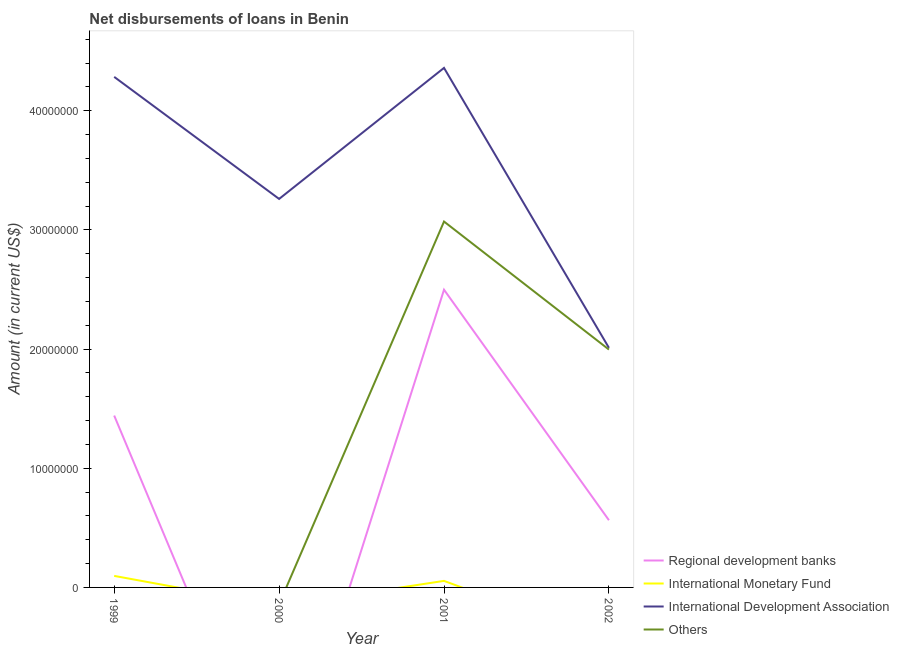How many different coloured lines are there?
Provide a succinct answer. 4. Is the number of lines equal to the number of legend labels?
Give a very brief answer. No. What is the amount of loan disimbursed by regional development banks in 2001?
Provide a succinct answer. 2.50e+07. Across all years, what is the maximum amount of loan disimbursed by other organisations?
Give a very brief answer. 3.07e+07. In which year was the amount of loan disimbursed by international development association maximum?
Give a very brief answer. 2001. What is the total amount of loan disimbursed by regional development banks in the graph?
Your answer should be very brief. 4.50e+07. What is the difference between the amount of loan disimbursed by international development association in 2001 and that in 2002?
Ensure brevity in your answer.  2.35e+07. What is the difference between the amount of loan disimbursed by international development association in 2001 and the amount of loan disimbursed by other organisations in 1999?
Offer a very short reply. 4.36e+07. What is the average amount of loan disimbursed by regional development banks per year?
Offer a terse response. 1.13e+07. In the year 2002, what is the difference between the amount of loan disimbursed by international development association and amount of loan disimbursed by regional development banks?
Give a very brief answer. 1.45e+07. What is the ratio of the amount of loan disimbursed by regional development banks in 1999 to that in 2001?
Provide a short and direct response. 0.58. What is the difference between the highest and the second highest amount of loan disimbursed by international development association?
Make the answer very short. 7.53e+05. What is the difference between the highest and the lowest amount of loan disimbursed by other organisations?
Your answer should be compact. 3.07e+07. In how many years, is the amount of loan disimbursed by international development association greater than the average amount of loan disimbursed by international development association taken over all years?
Offer a very short reply. 2. Is it the case that in every year, the sum of the amount of loan disimbursed by international development association and amount of loan disimbursed by regional development banks is greater than the sum of amount of loan disimbursed by other organisations and amount of loan disimbursed by international monetary fund?
Ensure brevity in your answer.  No. Is the amount of loan disimbursed by regional development banks strictly greater than the amount of loan disimbursed by other organisations over the years?
Give a very brief answer. No. Is the amount of loan disimbursed by regional development banks strictly less than the amount of loan disimbursed by international monetary fund over the years?
Offer a very short reply. No. How many lines are there?
Your answer should be compact. 4. How many years are there in the graph?
Keep it short and to the point. 4. What is the difference between two consecutive major ticks on the Y-axis?
Offer a very short reply. 1.00e+07. Does the graph contain any zero values?
Keep it short and to the point. Yes. How are the legend labels stacked?
Make the answer very short. Vertical. What is the title of the graph?
Your answer should be very brief. Net disbursements of loans in Benin. Does "Building human resources" appear as one of the legend labels in the graph?
Your response must be concise. No. What is the label or title of the X-axis?
Make the answer very short. Year. What is the label or title of the Y-axis?
Your answer should be compact. Amount (in current US$). What is the Amount (in current US$) in Regional development banks in 1999?
Ensure brevity in your answer.  1.44e+07. What is the Amount (in current US$) in International Monetary Fund in 1999?
Provide a short and direct response. 9.68e+05. What is the Amount (in current US$) in International Development Association in 1999?
Offer a terse response. 4.28e+07. What is the Amount (in current US$) in International Monetary Fund in 2000?
Your answer should be compact. 0. What is the Amount (in current US$) in International Development Association in 2000?
Your answer should be compact. 3.26e+07. What is the Amount (in current US$) of Others in 2000?
Make the answer very short. 0. What is the Amount (in current US$) in Regional development banks in 2001?
Provide a succinct answer. 2.50e+07. What is the Amount (in current US$) of International Monetary Fund in 2001?
Provide a succinct answer. 5.49e+05. What is the Amount (in current US$) of International Development Association in 2001?
Provide a succinct answer. 4.36e+07. What is the Amount (in current US$) in Others in 2001?
Make the answer very short. 3.07e+07. What is the Amount (in current US$) in Regional development banks in 2002?
Give a very brief answer. 5.64e+06. What is the Amount (in current US$) in International Monetary Fund in 2002?
Your answer should be compact. 0. What is the Amount (in current US$) in International Development Association in 2002?
Offer a very short reply. 2.01e+07. What is the Amount (in current US$) of Others in 2002?
Your answer should be compact. 2.00e+07. Across all years, what is the maximum Amount (in current US$) in Regional development banks?
Your answer should be compact. 2.50e+07. Across all years, what is the maximum Amount (in current US$) of International Monetary Fund?
Make the answer very short. 9.68e+05. Across all years, what is the maximum Amount (in current US$) of International Development Association?
Keep it short and to the point. 4.36e+07. Across all years, what is the maximum Amount (in current US$) of Others?
Keep it short and to the point. 3.07e+07. Across all years, what is the minimum Amount (in current US$) in Regional development banks?
Provide a short and direct response. 0. Across all years, what is the minimum Amount (in current US$) of International Monetary Fund?
Provide a short and direct response. 0. Across all years, what is the minimum Amount (in current US$) in International Development Association?
Give a very brief answer. 2.01e+07. Across all years, what is the minimum Amount (in current US$) of Others?
Your response must be concise. 0. What is the total Amount (in current US$) in Regional development banks in the graph?
Give a very brief answer. 4.50e+07. What is the total Amount (in current US$) in International Monetary Fund in the graph?
Your answer should be very brief. 1.52e+06. What is the total Amount (in current US$) of International Development Association in the graph?
Offer a very short reply. 1.39e+08. What is the total Amount (in current US$) in Others in the graph?
Offer a terse response. 5.07e+07. What is the difference between the Amount (in current US$) of International Development Association in 1999 and that in 2000?
Keep it short and to the point. 1.02e+07. What is the difference between the Amount (in current US$) of Regional development banks in 1999 and that in 2001?
Your answer should be compact. -1.06e+07. What is the difference between the Amount (in current US$) in International Monetary Fund in 1999 and that in 2001?
Provide a succinct answer. 4.19e+05. What is the difference between the Amount (in current US$) in International Development Association in 1999 and that in 2001?
Your answer should be compact. -7.53e+05. What is the difference between the Amount (in current US$) in Regional development banks in 1999 and that in 2002?
Your answer should be compact. 8.78e+06. What is the difference between the Amount (in current US$) of International Development Association in 1999 and that in 2002?
Provide a succinct answer. 2.27e+07. What is the difference between the Amount (in current US$) in International Development Association in 2000 and that in 2001?
Offer a very short reply. -1.10e+07. What is the difference between the Amount (in current US$) in International Development Association in 2000 and that in 2002?
Your answer should be very brief. 1.25e+07. What is the difference between the Amount (in current US$) of Regional development banks in 2001 and that in 2002?
Ensure brevity in your answer.  1.93e+07. What is the difference between the Amount (in current US$) of International Development Association in 2001 and that in 2002?
Ensure brevity in your answer.  2.35e+07. What is the difference between the Amount (in current US$) of Others in 2001 and that in 2002?
Your response must be concise. 1.07e+07. What is the difference between the Amount (in current US$) in Regional development banks in 1999 and the Amount (in current US$) in International Development Association in 2000?
Ensure brevity in your answer.  -1.82e+07. What is the difference between the Amount (in current US$) of International Monetary Fund in 1999 and the Amount (in current US$) of International Development Association in 2000?
Offer a terse response. -3.16e+07. What is the difference between the Amount (in current US$) of Regional development banks in 1999 and the Amount (in current US$) of International Monetary Fund in 2001?
Keep it short and to the point. 1.39e+07. What is the difference between the Amount (in current US$) of Regional development banks in 1999 and the Amount (in current US$) of International Development Association in 2001?
Ensure brevity in your answer.  -2.92e+07. What is the difference between the Amount (in current US$) of Regional development banks in 1999 and the Amount (in current US$) of Others in 2001?
Give a very brief answer. -1.63e+07. What is the difference between the Amount (in current US$) in International Monetary Fund in 1999 and the Amount (in current US$) in International Development Association in 2001?
Make the answer very short. -4.26e+07. What is the difference between the Amount (in current US$) of International Monetary Fund in 1999 and the Amount (in current US$) of Others in 2001?
Ensure brevity in your answer.  -2.97e+07. What is the difference between the Amount (in current US$) in International Development Association in 1999 and the Amount (in current US$) in Others in 2001?
Keep it short and to the point. 1.21e+07. What is the difference between the Amount (in current US$) of Regional development banks in 1999 and the Amount (in current US$) of International Development Association in 2002?
Keep it short and to the point. -5.68e+06. What is the difference between the Amount (in current US$) in Regional development banks in 1999 and the Amount (in current US$) in Others in 2002?
Provide a short and direct response. -5.54e+06. What is the difference between the Amount (in current US$) of International Monetary Fund in 1999 and the Amount (in current US$) of International Development Association in 2002?
Offer a terse response. -1.91e+07. What is the difference between the Amount (in current US$) of International Monetary Fund in 1999 and the Amount (in current US$) of Others in 2002?
Make the answer very short. -1.90e+07. What is the difference between the Amount (in current US$) of International Development Association in 1999 and the Amount (in current US$) of Others in 2002?
Offer a terse response. 2.29e+07. What is the difference between the Amount (in current US$) in International Development Association in 2000 and the Amount (in current US$) in Others in 2001?
Offer a terse response. 1.90e+06. What is the difference between the Amount (in current US$) in International Development Association in 2000 and the Amount (in current US$) in Others in 2002?
Your answer should be very brief. 1.26e+07. What is the difference between the Amount (in current US$) in Regional development banks in 2001 and the Amount (in current US$) in International Development Association in 2002?
Give a very brief answer. 4.88e+06. What is the difference between the Amount (in current US$) in Regional development banks in 2001 and the Amount (in current US$) in Others in 2002?
Your answer should be very brief. 5.02e+06. What is the difference between the Amount (in current US$) in International Monetary Fund in 2001 and the Amount (in current US$) in International Development Association in 2002?
Provide a succinct answer. -1.96e+07. What is the difference between the Amount (in current US$) in International Monetary Fund in 2001 and the Amount (in current US$) in Others in 2002?
Give a very brief answer. -1.94e+07. What is the difference between the Amount (in current US$) of International Development Association in 2001 and the Amount (in current US$) of Others in 2002?
Your response must be concise. 2.36e+07. What is the average Amount (in current US$) in Regional development banks per year?
Offer a terse response. 1.13e+07. What is the average Amount (in current US$) in International Monetary Fund per year?
Your answer should be very brief. 3.79e+05. What is the average Amount (in current US$) in International Development Association per year?
Keep it short and to the point. 3.48e+07. What is the average Amount (in current US$) in Others per year?
Offer a terse response. 1.27e+07. In the year 1999, what is the difference between the Amount (in current US$) in Regional development banks and Amount (in current US$) in International Monetary Fund?
Make the answer very short. 1.35e+07. In the year 1999, what is the difference between the Amount (in current US$) of Regional development banks and Amount (in current US$) of International Development Association?
Offer a very short reply. -2.84e+07. In the year 1999, what is the difference between the Amount (in current US$) in International Monetary Fund and Amount (in current US$) in International Development Association?
Offer a terse response. -4.19e+07. In the year 2001, what is the difference between the Amount (in current US$) of Regional development banks and Amount (in current US$) of International Monetary Fund?
Provide a succinct answer. 2.44e+07. In the year 2001, what is the difference between the Amount (in current US$) of Regional development banks and Amount (in current US$) of International Development Association?
Provide a short and direct response. -1.86e+07. In the year 2001, what is the difference between the Amount (in current US$) of Regional development banks and Amount (in current US$) of Others?
Your answer should be compact. -5.72e+06. In the year 2001, what is the difference between the Amount (in current US$) of International Monetary Fund and Amount (in current US$) of International Development Association?
Offer a very short reply. -4.31e+07. In the year 2001, what is the difference between the Amount (in current US$) of International Monetary Fund and Amount (in current US$) of Others?
Your response must be concise. -3.02e+07. In the year 2001, what is the difference between the Amount (in current US$) in International Development Association and Amount (in current US$) in Others?
Give a very brief answer. 1.29e+07. In the year 2002, what is the difference between the Amount (in current US$) in Regional development banks and Amount (in current US$) in International Development Association?
Offer a very short reply. -1.45e+07. In the year 2002, what is the difference between the Amount (in current US$) of Regional development banks and Amount (in current US$) of Others?
Your response must be concise. -1.43e+07. In the year 2002, what is the difference between the Amount (in current US$) in International Development Association and Amount (in current US$) in Others?
Offer a very short reply. 1.46e+05. What is the ratio of the Amount (in current US$) in International Development Association in 1999 to that in 2000?
Make the answer very short. 1.31. What is the ratio of the Amount (in current US$) of Regional development banks in 1999 to that in 2001?
Keep it short and to the point. 0.58. What is the ratio of the Amount (in current US$) in International Monetary Fund in 1999 to that in 2001?
Provide a succinct answer. 1.76. What is the ratio of the Amount (in current US$) in International Development Association in 1999 to that in 2001?
Your response must be concise. 0.98. What is the ratio of the Amount (in current US$) in Regional development banks in 1999 to that in 2002?
Your answer should be compact. 2.56. What is the ratio of the Amount (in current US$) in International Development Association in 1999 to that in 2002?
Ensure brevity in your answer.  2.13. What is the ratio of the Amount (in current US$) of International Development Association in 2000 to that in 2001?
Offer a terse response. 0.75. What is the ratio of the Amount (in current US$) of International Development Association in 2000 to that in 2002?
Ensure brevity in your answer.  1.62. What is the ratio of the Amount (in current US$) in Regional development banks in 2001 to that in 2002?
Give a very brief answer. 4.43. What is the ratio of the Amount (in current US$) in International Development Association in 2001 to that in 2002?
Keep it short and to the point. 2.17. What is the ratio of the Amount (in current US$) in Others in 2001 to that in 2002?
Provide a short and direct response. 1.54. What is the difference between the highest and the second highest Amount (in current US$) of Regional development banks?
Ensure brevity in your answer.  1.06e+07. What is the difference between the highest and the second highest Amount (in current US$) in International Development Association?
Your answer should be compact. 7.53e+05. What is the difference between the highest and the lowest Amount (in current US$) of Regional development banks?
Offer a terse response. 2.50e+07. What is the difference between the highest and the lowest Amount (in current US$) of International Monetary Fund?
Offer a terse response. 9.68e+05. What is the difference between the highest and the lowest Amount (in current US$) of International Development Association?
Your response must be concise. 2.35e+07. What is the difference between the highest and the lowest Amount (in current US$) of Others?
Your answer should be very brief. 3.07e+07. 